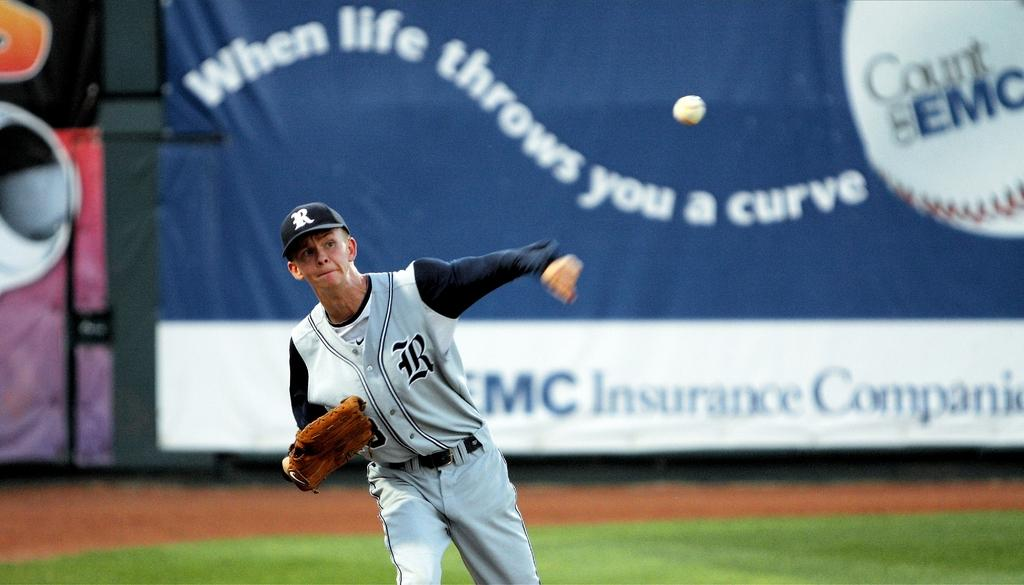<image>
Provide a brief description of the given image. A baseball player is throwing a ball and has the word when above him. 